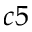<formula> <loc_0><loc_0><loc_500><loc_500>c 5</formula> 